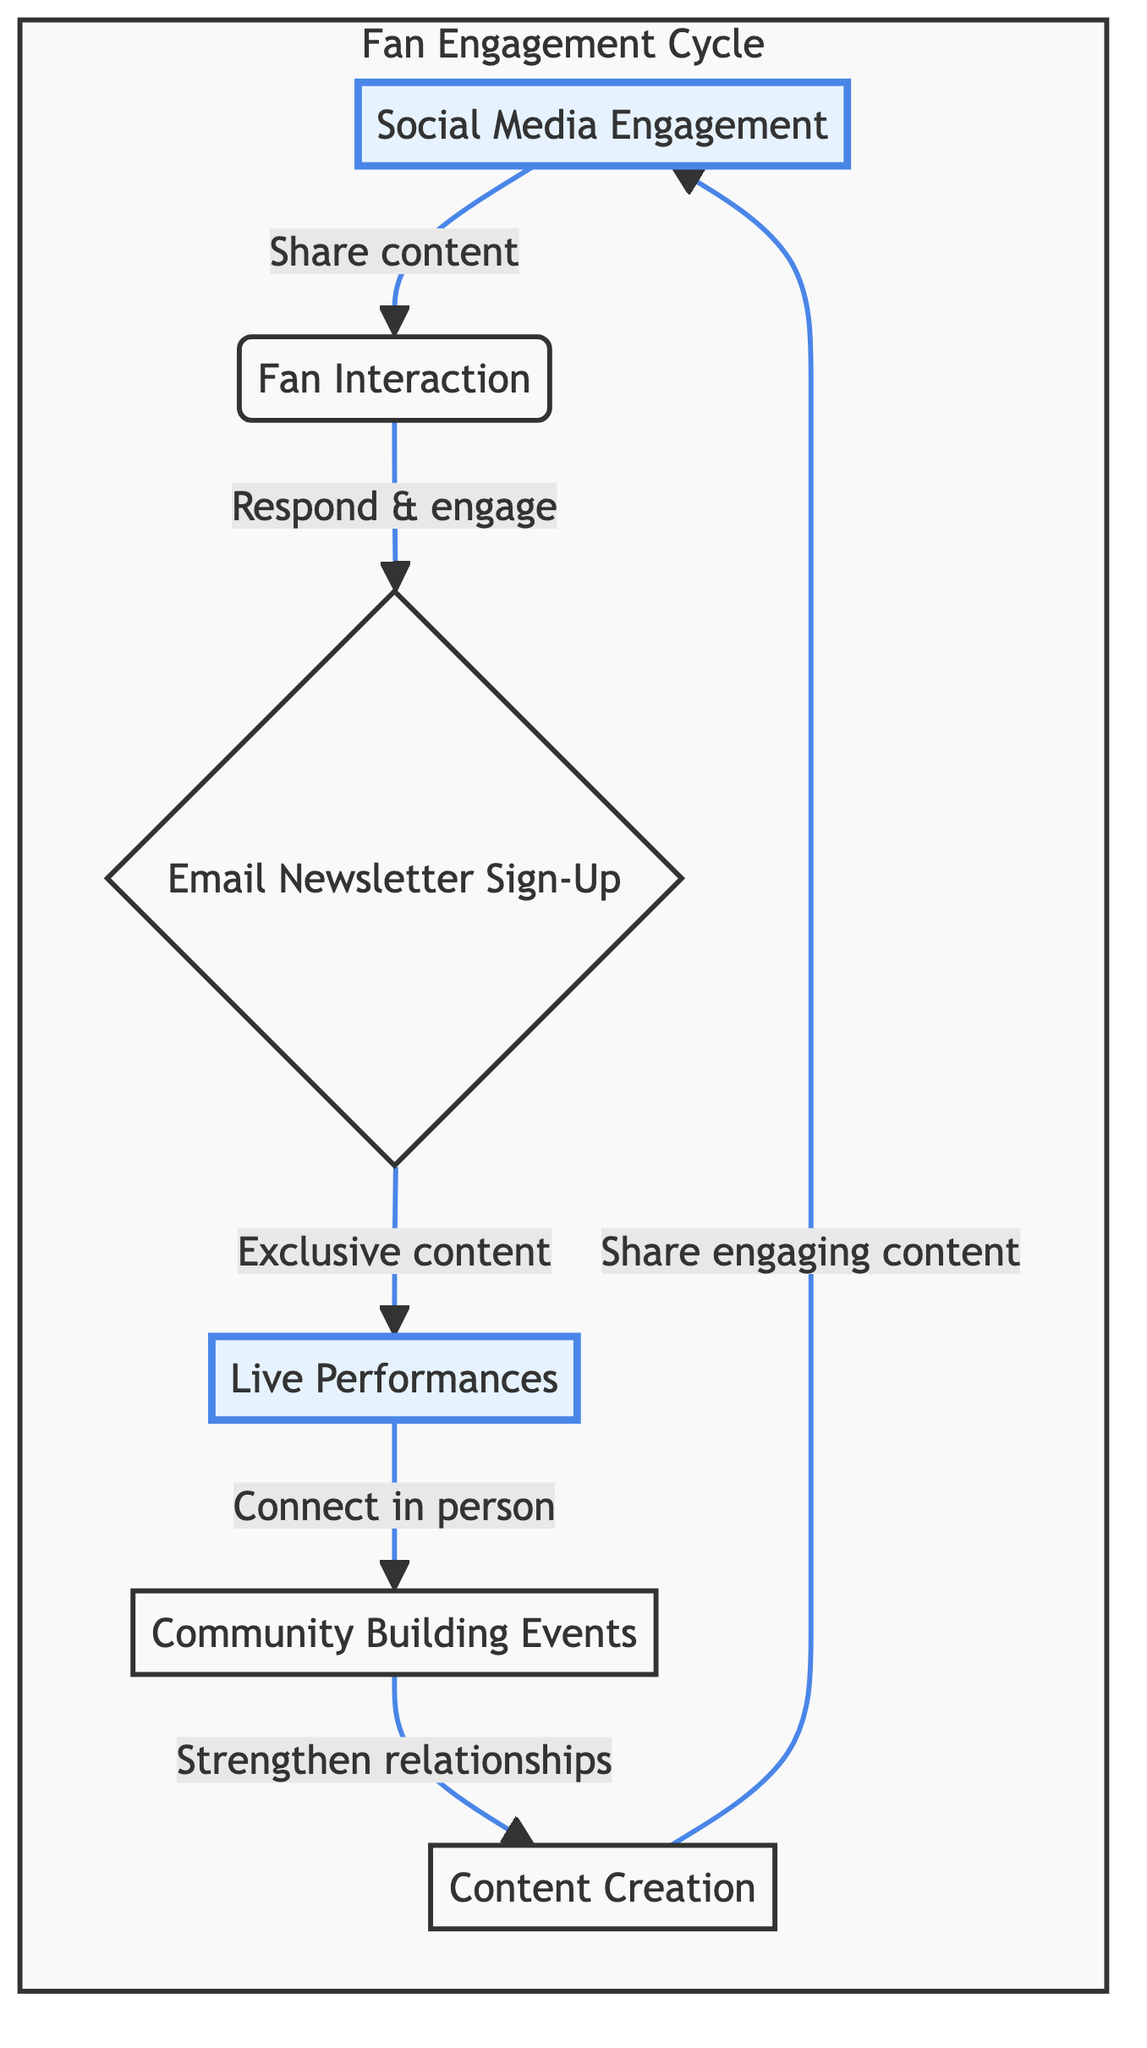What is the first step in the fan engagement cycle? The diagram indicates that the first step is "Social Media Engagement." This can be identified as it is the starting node with an outgoing edge leading to the next step, "Fan Interaction."
Answer: Social Media Engagement How many main nodes are in the diagram? There are six main nodes, including "Social Media Engagement," "Fan Interaction," "Email Newsletter Sign-Up," "Live Performances," "Community Building Events," and "Content Creation." This count is based on the distinct sections represented in the flow chart.
Answer: Six What action follows "Fan Interaction"? After "Fan Interaction," the flow leads to "Email Newsletter Sign-Up." This is shown by the direct arrow connecting these two nodes in the flow chart.
Answer: Email Newsletter Sign-Up What relationship does "Live Performances" have with "Community Building Events"? The relationship is that "Live Performances" is connected to "Community Building Events" by the action "Connect in person." This indicates that organizing community events may stem from interactions during live performances.
Answer: Connect in person Which two nodes have a highlighted status? The two highlighted nodes are "Social Media Engagement" and "Live Performances." Highlighting is used to emphasize specific points in the flow chart and indicate important actions or stages in the engagement cycle.
Answer: Social Media Engagement, Live Performances How does "Content Creation" relate to the cycle? "Content Creation" is connected back to "Social Media Engagement." This means that after creating engaging content, it is then shared on social media, completing the cycle by reinforcing the engagement with fans.
Answer: Reinforcing engagement Which node has a connection leading to the next step after "Email Newsletter Sign-Up"? The node that follows "Email Newsletter Sign-Up" is "Live Performances," as denoted by the arrow indicating the flow of the engagement process.
Answer: Live Performances What type of engagement is represented by "Community Building Events"? "Community Building Events" represents interactive events such as meet-and-greet sessions or listening parties. This information is derived from the description associated with this node in the flow chart.
Answer: Interactive events 